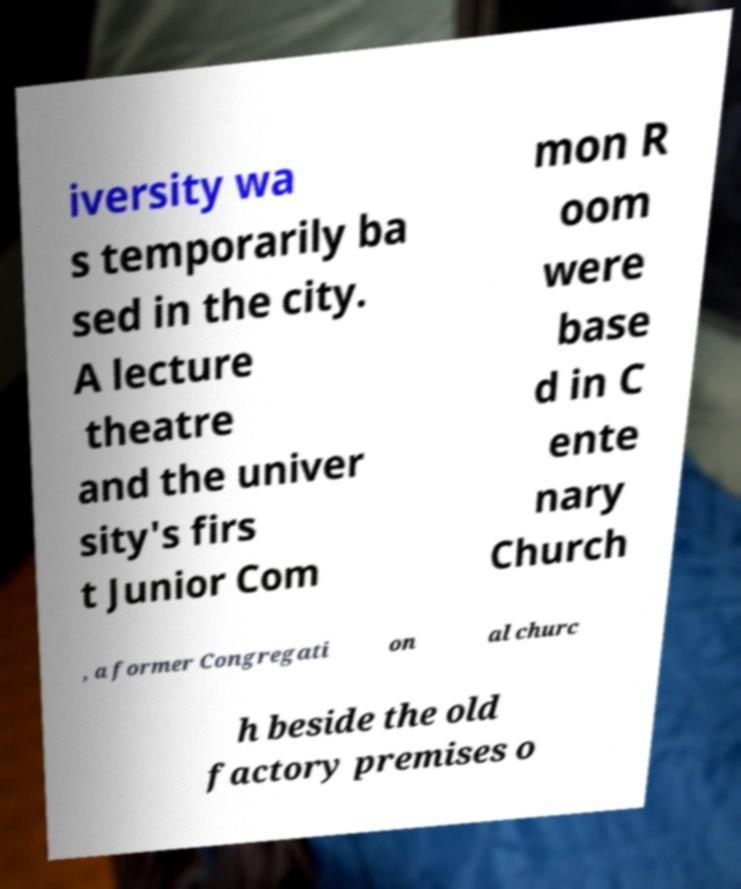There's text embedded in this image that I need extracted. Can you transcribe it verbatim? iversity wa s temporarily ba sed in the city. A lecture theatre and the univer sity's firs t Junior Com mon R oom were base d in C ente nary Church , a former Congregati on al churc h beside the old factory premises o 